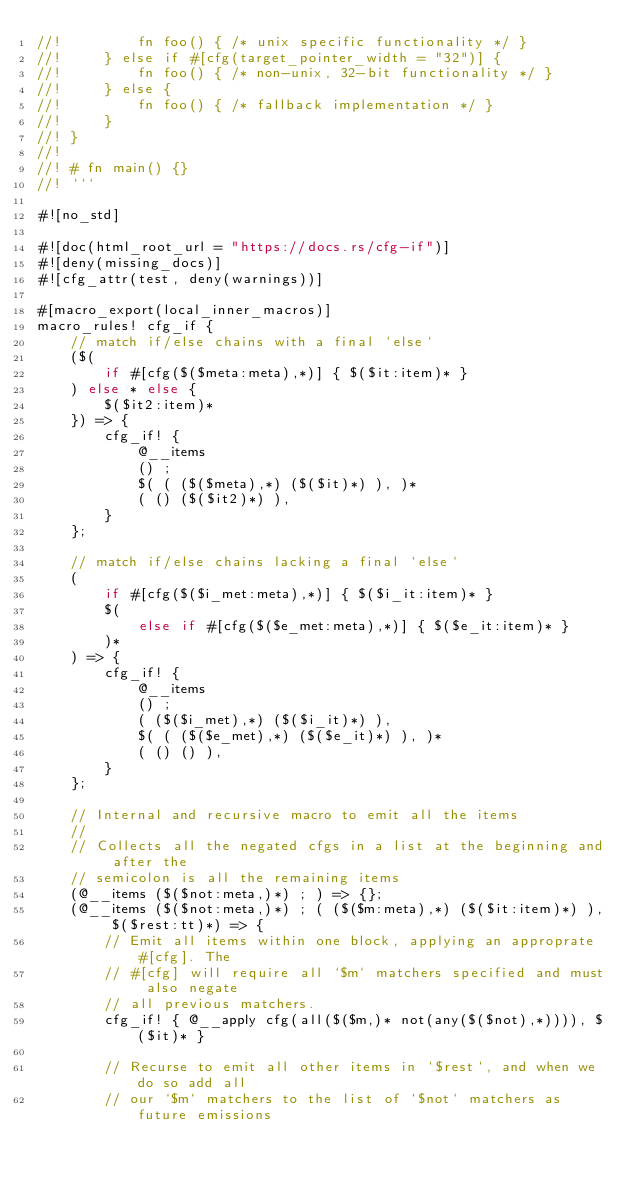<code> <loc_0><loc_0><loc_500><loc_500><_Rust_>//!         fn foo() { /* unix specific functionality */ }
//!     } else if #[cfg(target_pointer_width = "32")] {
//!         fn foo() { /* non-unix, 32-bit functionality */ }
//!     } else {
//!         fn foo() { /* fallback implementation */ }
//!     }
//! }
//!
//! # fn main() {}
//! ```

#![no_std]

#![doc(html_root_url = "https://docs.rs/cfg-if")]
#![deny(missing_docs)]
#![cfg_attr(test, deny(warnings))]

#[macro_export(local_inner_macros)]
macro_rules! cfg_if {
    // match if/else chains with a final `else`
    ($(
        if #[cfg($($meta:meta),*)] { $($it:item)* }
    ) else * else {
        $($it2:item)*
    }) => {
        cfg_if! {
            @__items
            () ;
            $( ( ($($meta),*) ($($it)*) ), )*
            ( () ($($it2)*) ),
        }
    };

    // match if/else chains lacking a final `else`
    (
        if #[cfg($($i_met:meta),*)] { $($i_it:item)* }
        $(
            else if #[cfg($($e_met:meta),*)] { $($e_it:item)* }
        )*
    ) => {
        cfg_if! {
            @__items
            () ;
            ( ($($i_met),*) ($($i_it)*) ),
            $( ( ($($e_met),*) ($($e_it)*) ), )*
            ( () () ),
        }
    };

    // Internal and recursive macro to emit all the items
    //
    // Collects all the negated cfgs in a list at the beginning and after the
    // semicolon is all the remaining items
    (@__items ($($not:meta,)*) ; ) => {};
    (@__items ($($not:meta,)*) ; ( ($($m:meta),*) ($($it:item)*) ), $($rest:tt)*) => {
        // Emit all items within one block, applying an approprate #[cfg]. The
        // #[cfg] will require all `$m` matchers specified and must also negate
        // all previous matchers.
        cfg_if! { @__apply cfg(all($($m,)* not(any($($not),*)))), $($it)* }

        // Recurse to emit all other items in `$rest`, and when we do so add all
        // our `$m` matchers to the list of `$not` matchers as future emissions</code> 